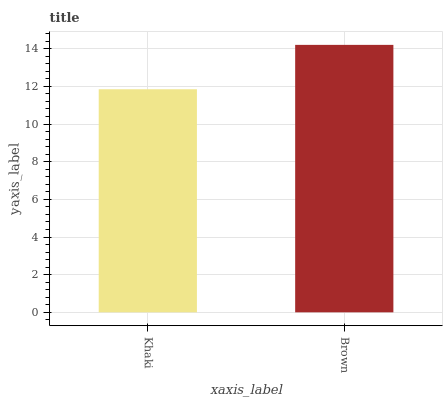Is Khaki the minimum?
Answer yes or no. Yes. Is Brown the maximum?
Answer yes or no. Yes. Is Brown the minimum?
Answer yes or no. No. Is Brown greater than Khaki?
Answer yes or no. Yes. Is Khaki less than Brown?
Answer yes or no. Yes. Is Khaki greater than Brown?
Answer yes or no. No. Is Brown less than Khaki?
Answer yes or no. No. Is Brown the high median?
Answer yes or no. Yes. Is Khaki the low median?
Answer yes or no. Yes. Is Khaki the high median?
Answer yes or no. No. Is Brown the low median?
Answer yes or no. No. 